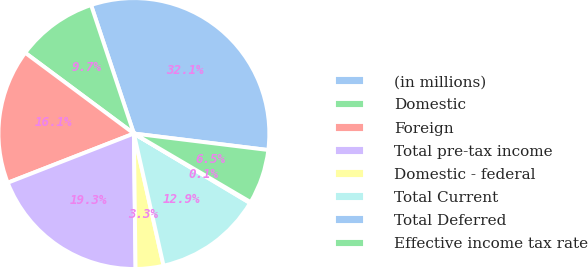Convert chart to OTSL. <chart><loc_0><loc_0><loc_500><loc_500><pie_chart><fcel>(in millions)<fcel>Domestic<fcel>Foreign<fcel>Total pre-tax income<fcel>Domestic - federal<fcel>Total Current<fcel>Total Deferred<fcel>Effective income tax rate<nl><fcel>32.06%<fcel>9.71%<fcel>16.09%<fcel>19.28%<fcel>3.32%<fcel>12.9%<fcel>0.13%<fcel>6.51%<nl></chart> 